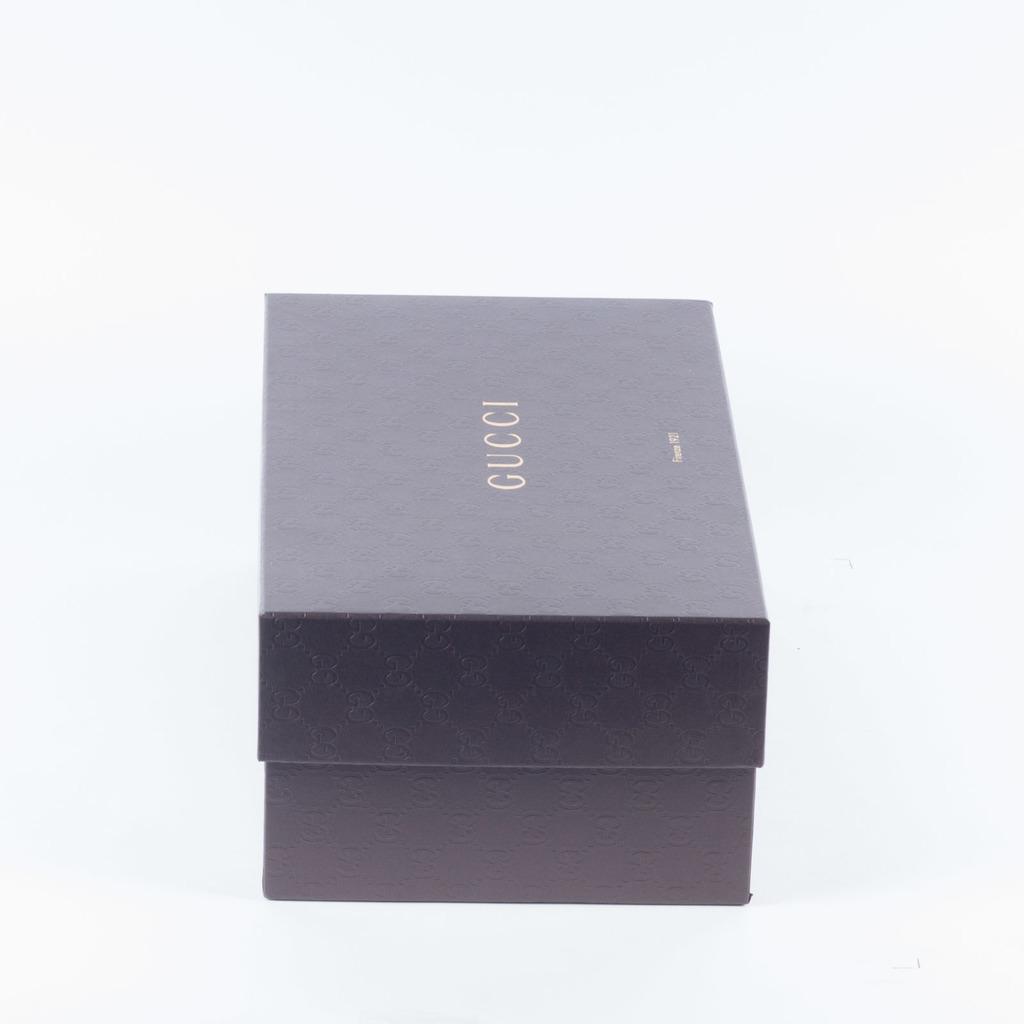What brand is on the box?
Make the answer very short. Gucci. 